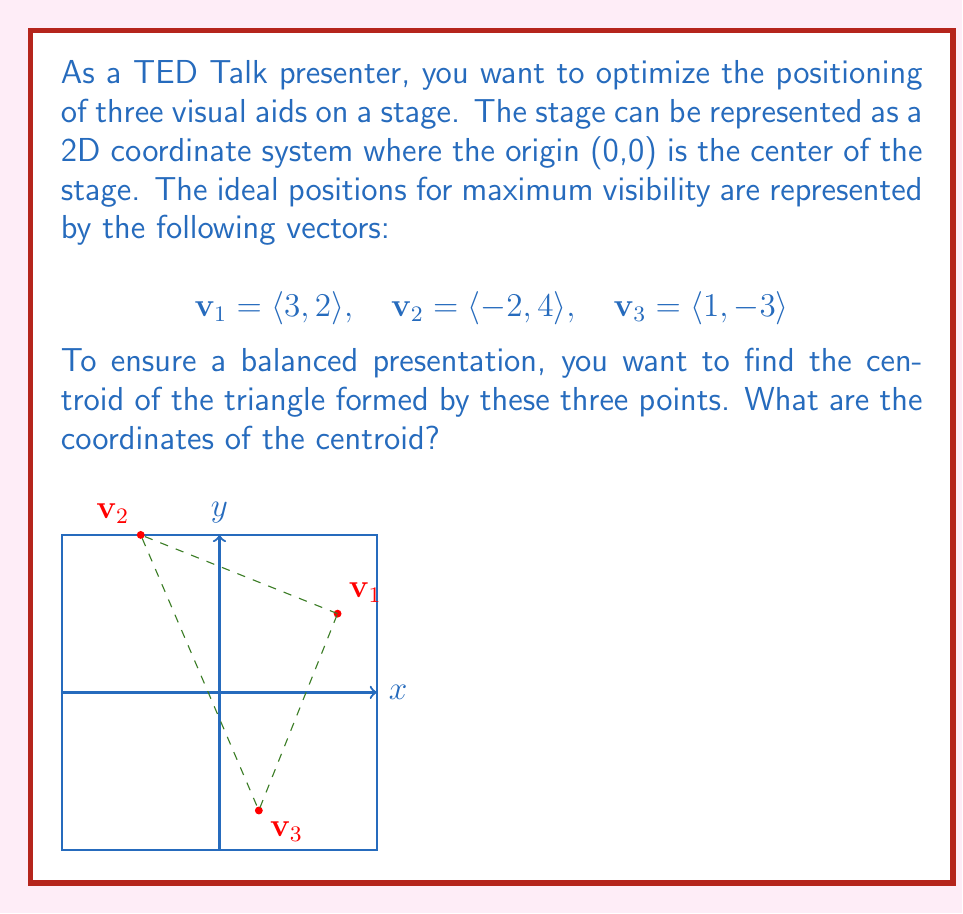Solve this math problem. To find the centroid of the triangle formed by the three visual aid positions, we need to follow these steps:

1) Recall that the centroid of a triangle is located at the arithmetic mean of the coordinates of its vertices.

2) Let's denote the centroid as $\mathbf{c} = \langle x, y \rangle$.

3) To find the x-coordinate of the centroid:
   $$x = \frac{x_1 + x_2 + x_3}{3} = \frac{3 + (-2) + 1}{3} = \frac{2}{3}$$

4) To find the y-coordinate of the centroid:
   $$y = \frac{y_1 + y_2 + y_3}{3} = \frac{2 + 4 + (-3)}{3} = 1$$

5) Therefore, the centroid $\mathbf{c}$ is located at $\langle \frac{2}{3}, 1 \rangle$.

This point represents the optimal position for you as a presenter to stand, ensuring balanced proximity to all visual aids and maintaining good stage presence.
Answer: $\langle \frac{2}{3}, 1 \rangle$ 